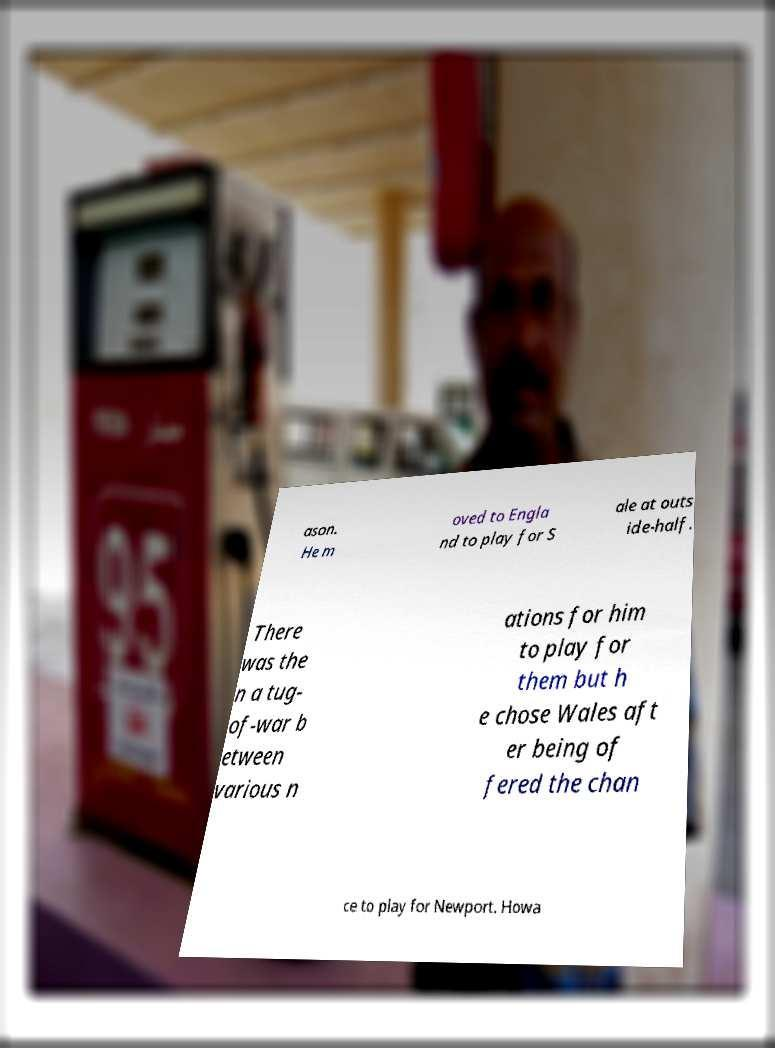There's text embedded in this image that I need extracted. Can you transcribe it verbatim? ason. He m oved to Engla nd to play for S ale at outs ide-half. There was the n a tug- of-war b etween various n ations for him to play for them but h e chose Wales aft er being of fered the chan ce to play for Newport. Howa 